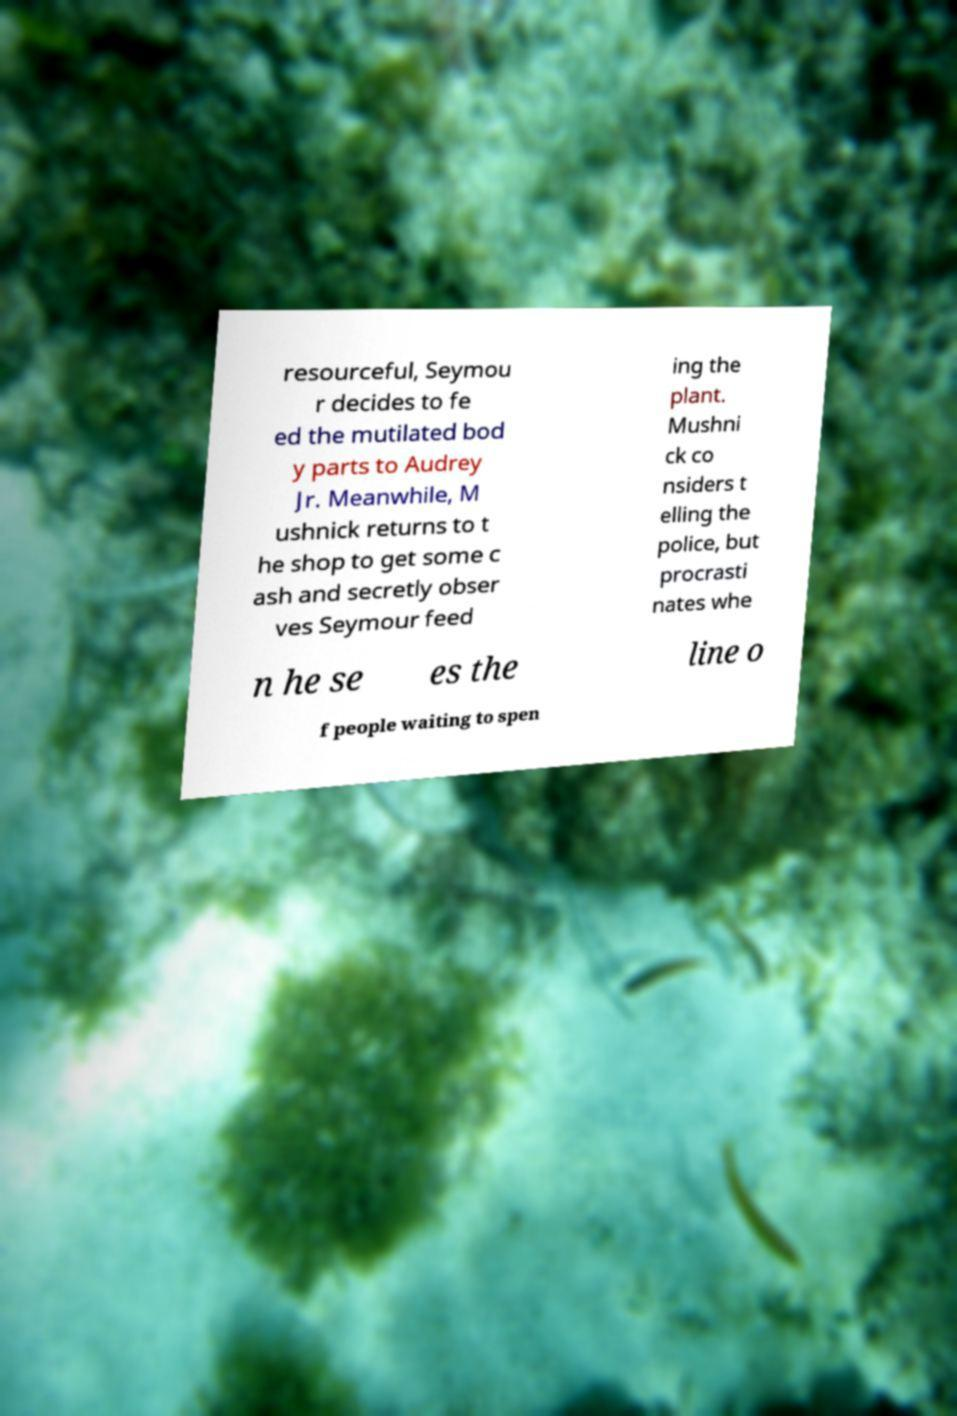For documentation purposes, I need the text within this image transcribed. Could you provide that? resourceful, Seymou r decides to fe ed the mutilated bod y parts to Audrey Jr. Meanwhile, M ushnick returns to t he shop to get some c ash and secretly obser ves Seymour feed ing the plant. Mushni ck co nsiders t elling the police, but procrasti nates whe n he se es the line o f people waiting to spen 